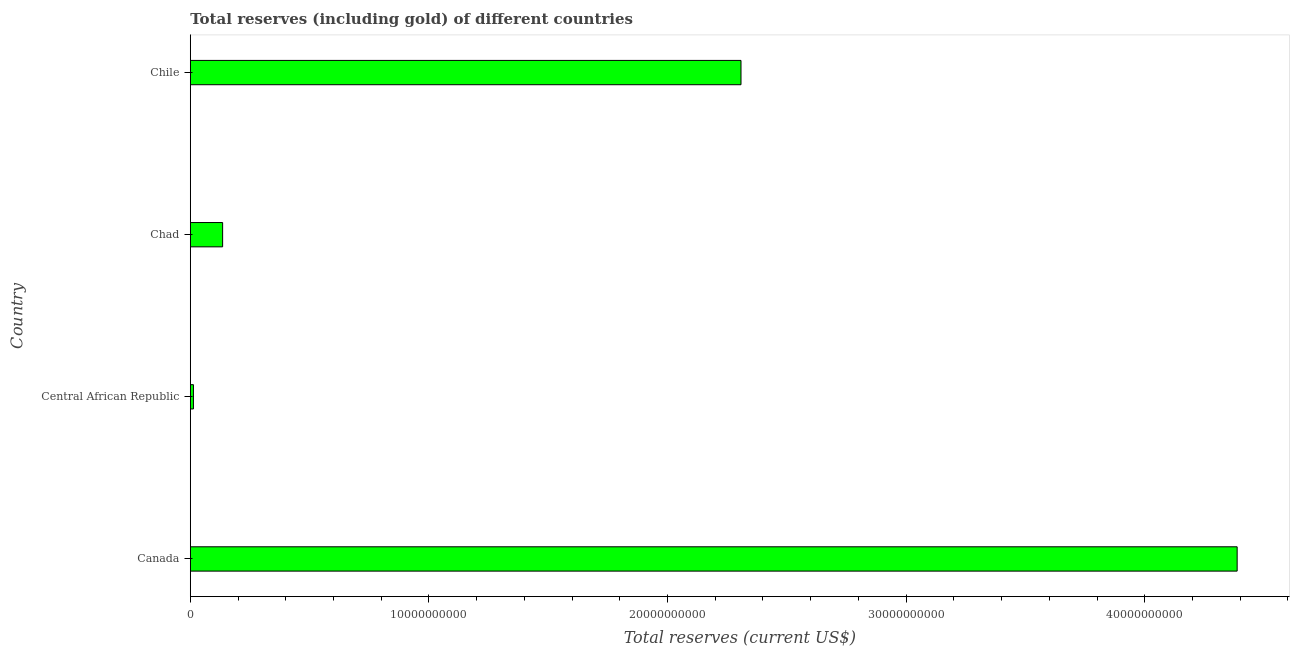Does the graph contain any zero values?
Offer a very short reply. No. What is the title of the graph?
Your answer should be compact. Total reserves (including gold) of different countries. What is the label or title of the X-axis?
Provide a short and direct response. Total reserves (current US$). What is the label or title of the Y-axis?
Give a very brief answer. Country. What is the total reserves (including gold) in Chile?
Keep it short and to the point. 2.31e+1. Across all countries, what is the maximum total reserves (including gold)?
Offer a very short reply. 4.39e+1. Across all countries, what is the minimum total reserves (including gold)?
Offer a very short reply. 1.31e+08. In which country was the total reserves (including gold) maximum?
Provide a short and direct response. Canada. In which country was the total reserves (including gold) minimum?
Your response must be concise. Central African Republic. What is the sum of the total reserves (including gold)?
Make the answer very short. 6.84e+1. What is the difference between the total reserves (including gold) in Central African Republic and Chile?
Your answer should be very brief. -2.29e+1. What is the average total reserves (including gold) per country?
Provide a short and direct response. 1.71e+1. What is the median total reserves (including gold)?
Provide a short and direct response. 1.22e+1. In how many countries, is the total reserves (including gold) greater than 40000000000 US$?
Offer a very short reply. 1. What is the ratio of the total reserves (including gold) in Canada to that in Chad?
Keep it short and to the point. 32.38. What is the difference between the highest and the second highest total reserves (including gold)?
Keep it short and to the point. 2.08e+1. Is the sum of the total reserves (including gold) in Central African Republic and Chile greater than the maximum total reserves (including gold) across all countries?
Provide a succinct answer. No. What is the difference between the highest and the lowest total reserves (including gold)?
Your answer should be compact. 4.37e+1. In how many countries, is the total reserves (including gold) greater than the average total reserves (including gold) taken over all countries?
Ensure brevity in your answer.  2. How many bars are there?
Offer a terse response. 4. Are the values on the major ticks of X-axis written in scientific E-notation?
Provide a succinct answer. No. What is the Total reserves (current US$) in Canada?
Your answer should be very brief. 4.39e+1. What is the Total reserves (current US$) in Central African Republic?
Your answer should be very brief. 1.31e+08. What is the Total reserves (current US$) of Chad?
Offer a very short reply. 1.36e+09. What is the Total reserves (current US$) in Chile?
Provide a succinct answer. 2.31e+1. What is the difference between the Total reserves (current US$) in Canada and Central African Republic?
Offer a very short reply. 4.37e+1. What is the difference between the Total reserves (current US$) in Canada and Chad?
Provide a succinct answer. 4.25e+1. What is the difference between the Total reserves (current US$) in Canada and Chile?
Offer a terse response. 2.08e+1. What is the difference between the Total reserves (current US$) in Central African Republic and Chad?
Your response must be concise. -1.22e+09. What is the difference between the Total reserves (current US$) in Central African Republic and Chile?
Provide a short and direct response. -2.29e+1. What is the difference between the Total reserves (current US$) in Chad and Chile?
Ensure brevity in your answer.  -2.17e+1. What is the ratio of the Total reserves (current US$) in Canada to that in Central African Republic?
Offer a very short reply. 333.71. What is the ratio of the Total reserves (current US$) in Canada to that in Chad?
Your answer should be very brief. 32.38. What is the ratio of the Total reserves (current US$) in Canada to that in Chile?
Make the answer very short. 1.9. What is the ratio of the Total reserves (current US$) in Central African Republic to that in Chad?
Offer a very short reply. 0.1. What is the ratio of the Total reserves (current US$) in Central African Republic to that in Chile?
Provide a succinct answer. 0.01. What is the ratio of the Total reserves (current US$) in Chad to that in Chile?
Ensure brevity in your answer.  0.06. 